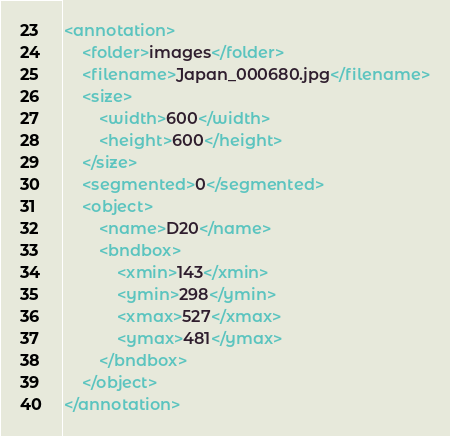Convert code to text. <code><loc_0><loc_0><loc_500><loc_500><_XML_><annotation>
    <folder>images</folder>
    <filename>Japan_000680.jpg</filename>
    <size>
        <width>600</width>
        <height>600</height>
    </size>
    <segmented>0</segmented>
    <object>
        <name>D20</name>
        <bndbox>
            <xmin>143</xmin>
            <ymin>298</ymin>
            <xmax>527</xmax>
            <ymax>481</ymax>
        </bndbox>
    </object>
</annotation></code> 